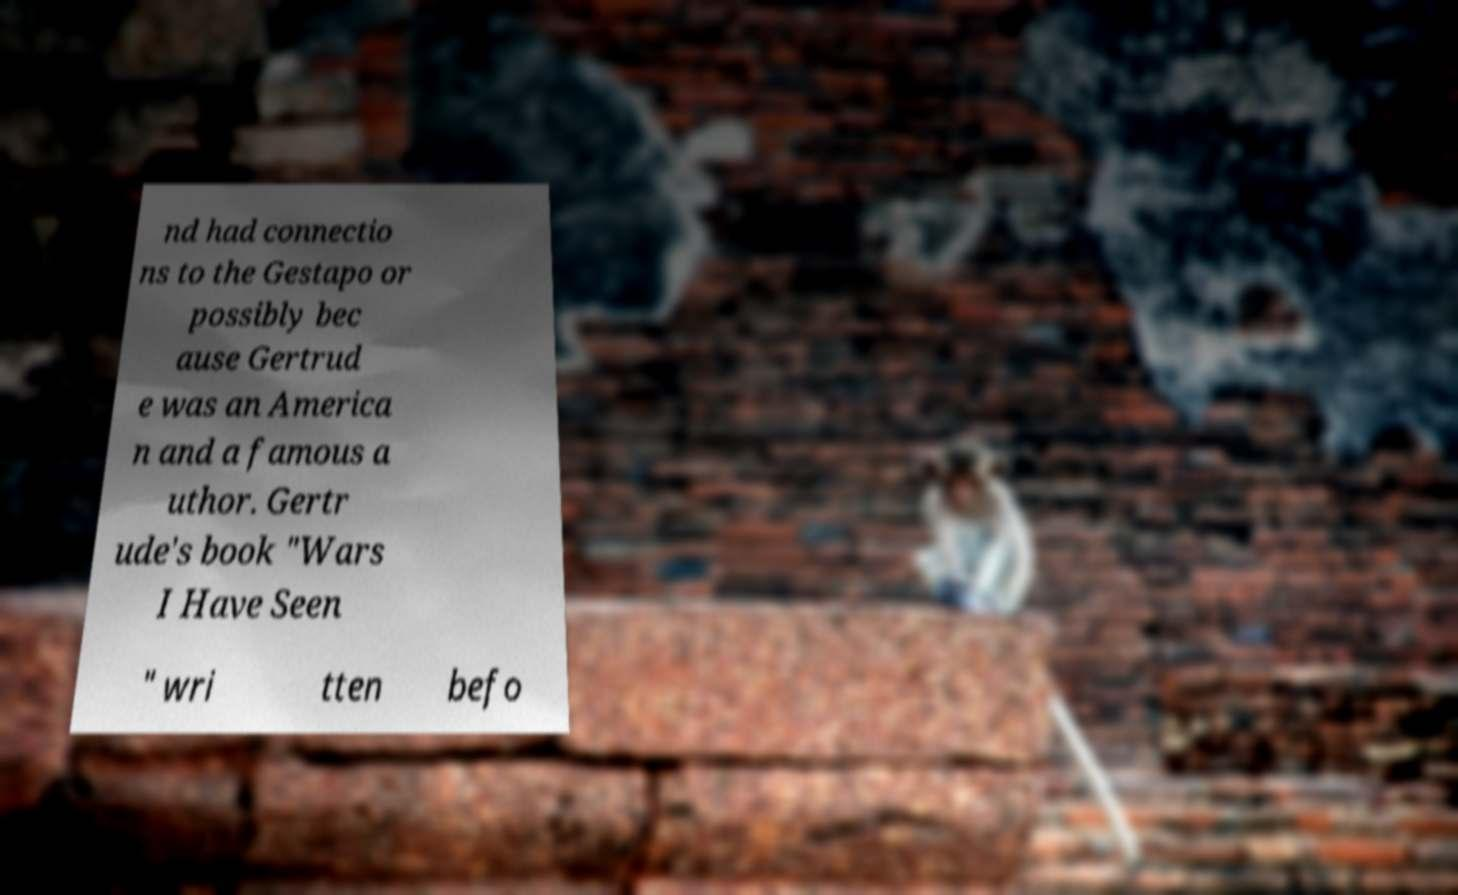Could you extract and type out the text from this image? nd had connectio ns to the Gestapo or possibly bec ause Gertrud e was an America n and a famous a uthor. Gertr ude's book "Wars I Have Seen " wri tten befo 